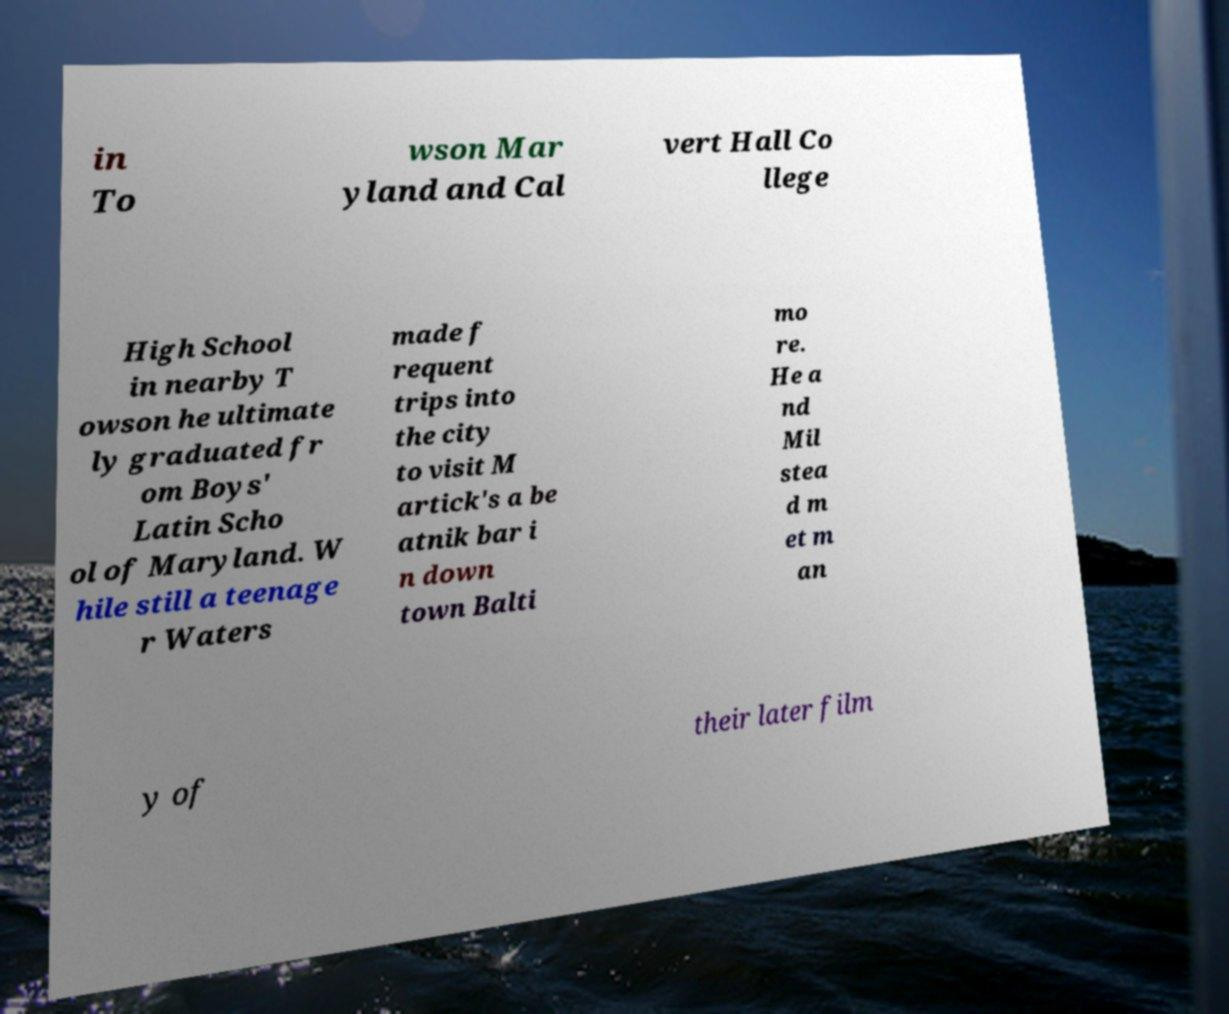I need the written content from this picture converted into text. Can you do that? in To wson Mar yland and Cal vert Hall Co llege High School in nearby T owson he ultimate ly graduated fr om Boys' Latin Scho ol of Maryland. W hile still a teenage r Waters made f requent trips into the city to visit M artick's a be atnik bar i n down town Balti mo re. He a nd Mil stea d m et m an y of their later film 